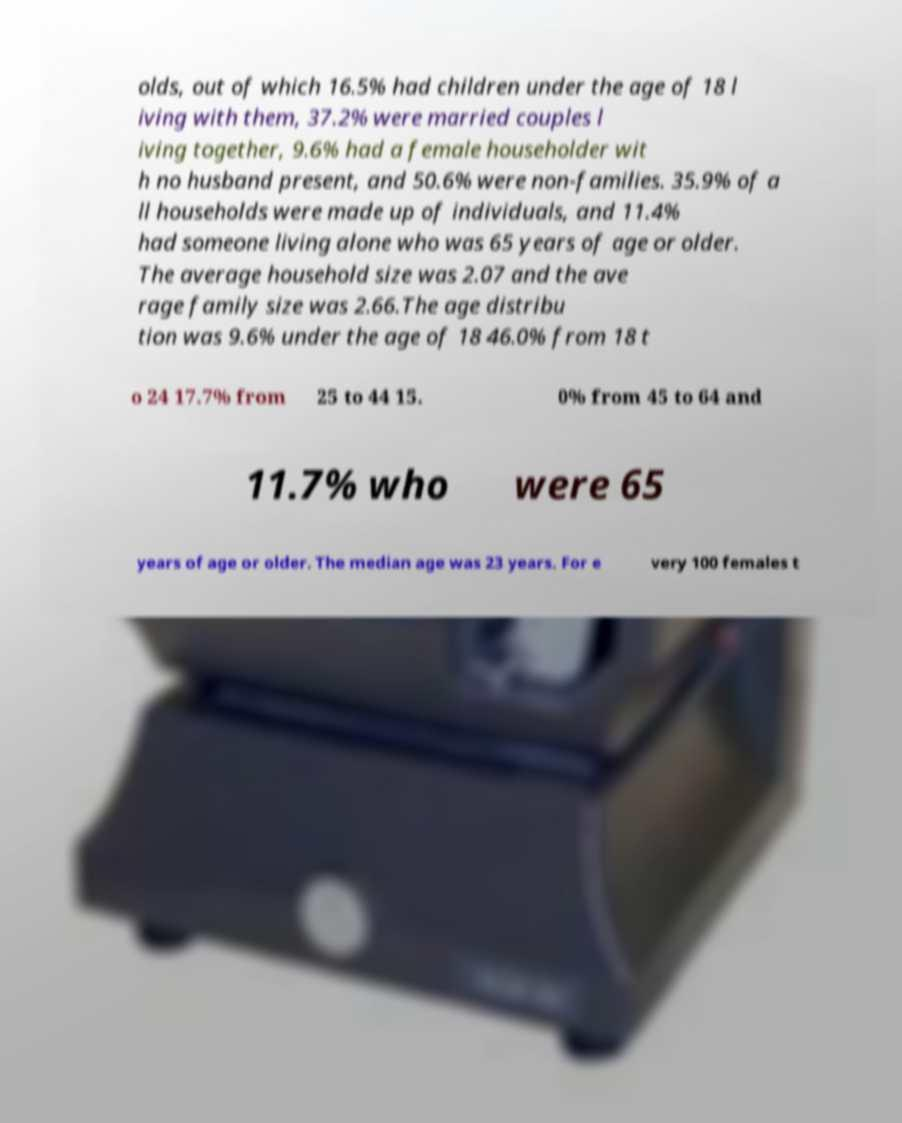Please identify and transcribe the text found in this image. olds, out of which 16.5% had children under the age of 18 l iving with them, 37.2% were married couples l iving together, 9.6% had a female householder wit h no husband present, and 50.6% were non-families. 35.9% of a ll households were made up of individuals, and 11.4% had someone living alone who was 65 years of age or older. The average household size was 2.07 and the ave rage family size was 2.66.The age distribu tion was 9.6% under the age of 18 46.0% from 18 t o 24 17.7% from 25 to 44 15. 0% from 45 to 64 and 11.7% who were 65 years of age or older. The median age was 23 years. For e very 100 females t 